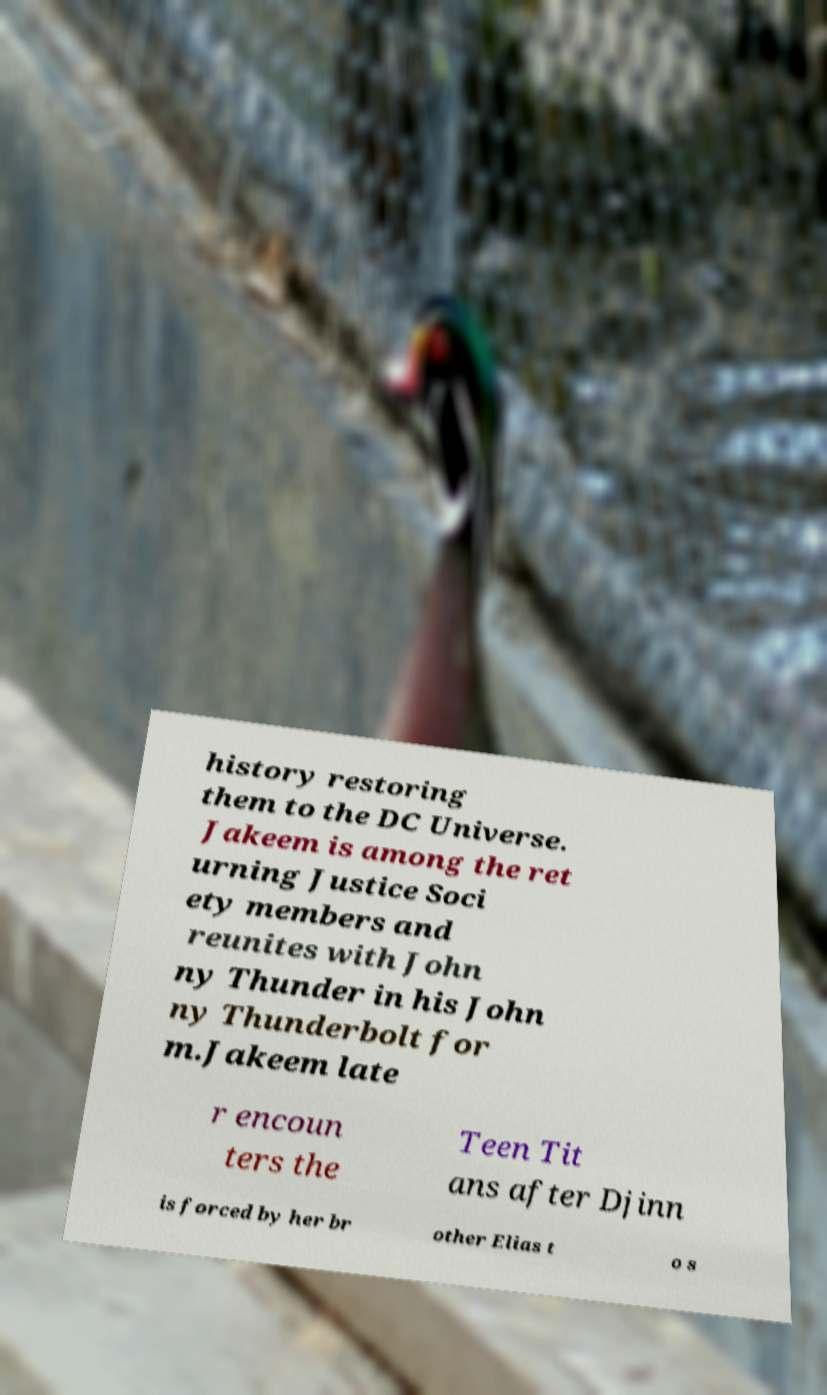Please read and relay the text visible in this image. What does it say? history restoring them to the DC Universe. Jakeem is among the ret urning Justice Soci ety members and reunites with John ny Thunder in his John ny Thunderbolt for m.Jakeem late r encoun ters the Teen Tit ans after Djinn is forced by her br other Elias t o s 